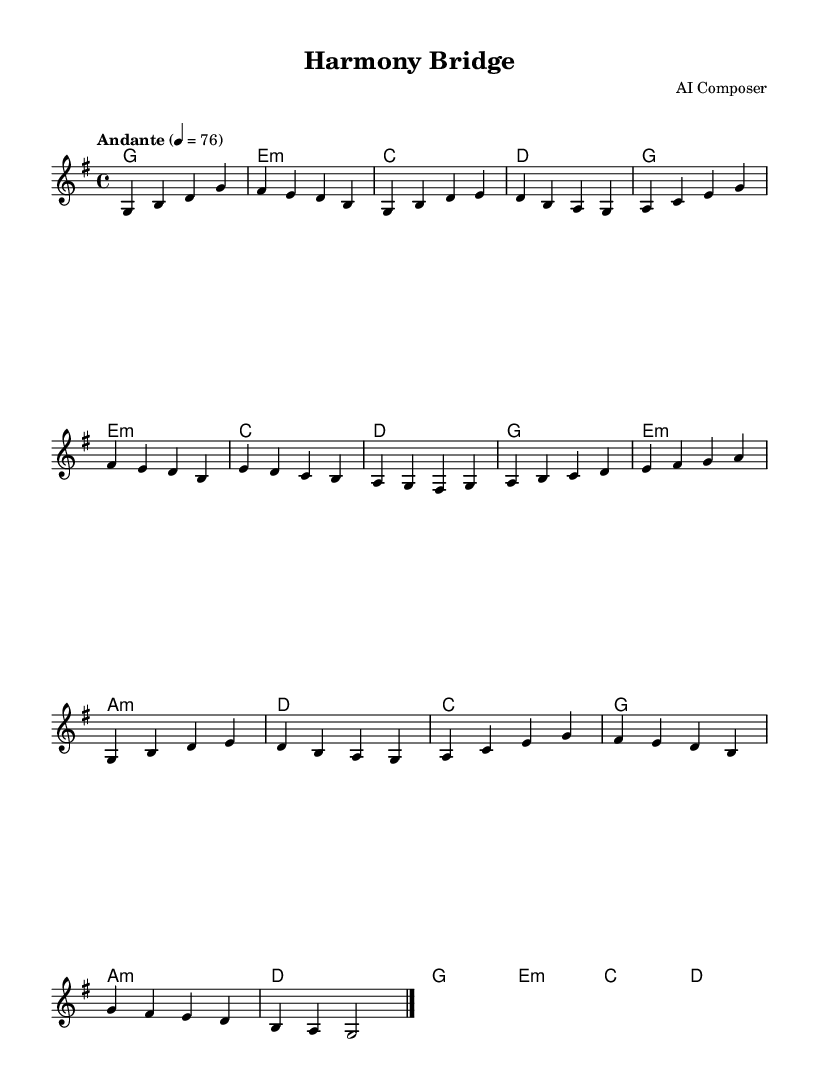What is the key signature of this music? The key signature is G major, which has one sharp (F#). This can be identified by looking at the beginning of the staff where the sharps are indicated.
Answer: G major What is the time signature of this piece? The time signature is 4/4, which means there are four beats in each measure. This can be found at the beginning of the piece next to the key signature.
Answer: 4/4 What is the tempo marking for this piece? The tempo marking is "Andante," which indicates a moderately slow pace. The tempo indication is present above the staff, specifying the speed of the music.
Answer: Andante How many sections are there in this piece? The piece comprises three main sections: A, B, and A', each with distinct melodic patterns. This can be seen in the structure of the melody as identified by repeated letters.
Answer: Three What type of harmonies are used for the A section? The A section primarily uses major and minor chords, specifically G major, E minor, and A minor among others. This is deduced by analyzing the chord names provided below the staff corresponding to the melody.
Answer: Major and minor chords Which section is repeated in the piece? The A section is repeated in A', indicated by the same melodic notes played again. This is noted by the use of the letter A' after the B section, signifying a return to the previous material.
Answer: A section What does the outro indicate for the performance? The outro suggests a conclusion, marked by slowing down the music as indicated by the final measures ending on a G chord. This indicates a resolution to the piece as it harmonically resolves.
Answer: Conclusion 